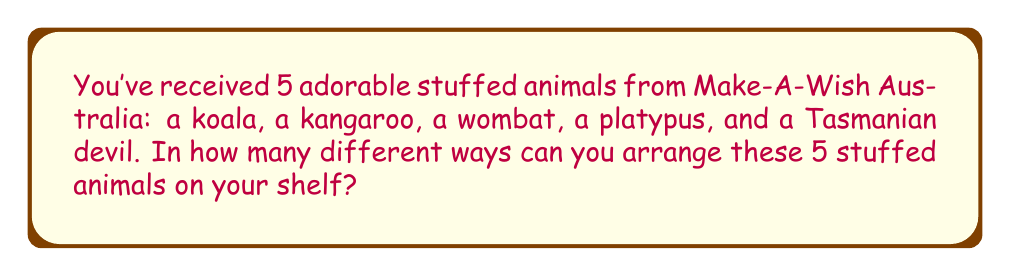Teach me how to tackle this problem. Let's approach this step-by-step:

1) First, we need to understand that this is a permutation problem. We're arranging all 5 stuffed animals, and the order matters.

2) In permutation problems where all items are used and each item can only be used once, we use the formula:

   $$ P(n) = n! $$

   Where $n$ is the number of items we're arranging.

3) In this case, we have 5 stuffed animals, so $n = 5$.

4) Let's calculate $5!$:
   
   $$ 5! = 5 \times 4 \times 3 \times 2 \times 1 = 120 $$

5) This means there are 120 different ways to arrange the stuffed animals.

To understand why:
- For the first position, you have 5 choices.
- For the second position, you now have 4 choices left.
- For the third position, 3 choices remain.
- For the fourth position, 2 choices are left.
- For the last position, only 1 choice remains.

Multiplying these together gives us $5 \times 4 \times 3 \times 2 \times 1 = 120$.
Answer: 120 